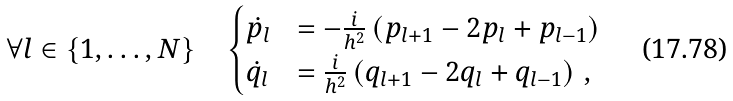<formula> <loc_0><loc_0><loc_500><loc_500>\forall l \in \{ 1 , \dots , N \} \quad \begin{cases} \dot { p _ { l } } & = - \frac { i } { h ^ { 2 } } \left ( p _ { l + 1 } - 2 p _ { l } + p _ { l - 1 } \right ) \\ \dot { q _ { l } } & = \frac { i } { h ^ { 2 } } \left ( q _ { l + 1 } - 2 q _ { l } + q _ { l - 1 } \right ) \, , \end{cases}</formula> 